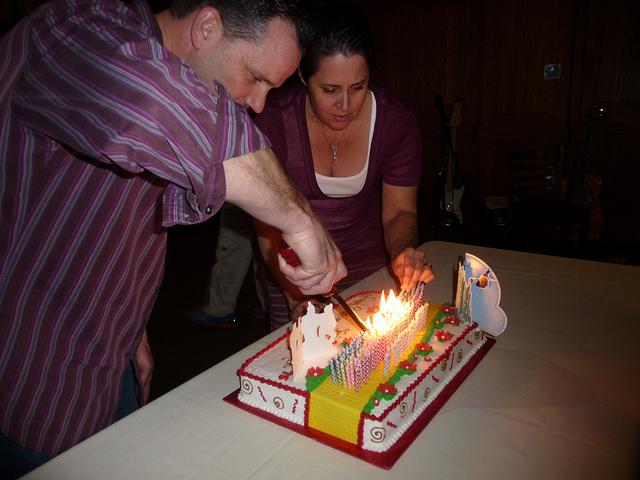Is the woman wearing a necklace?
Write a very short answer. Yes. Who cuts a cake?
Quick response, please. Man. How many different colored candles are there?
Write a very short answer. 3. 